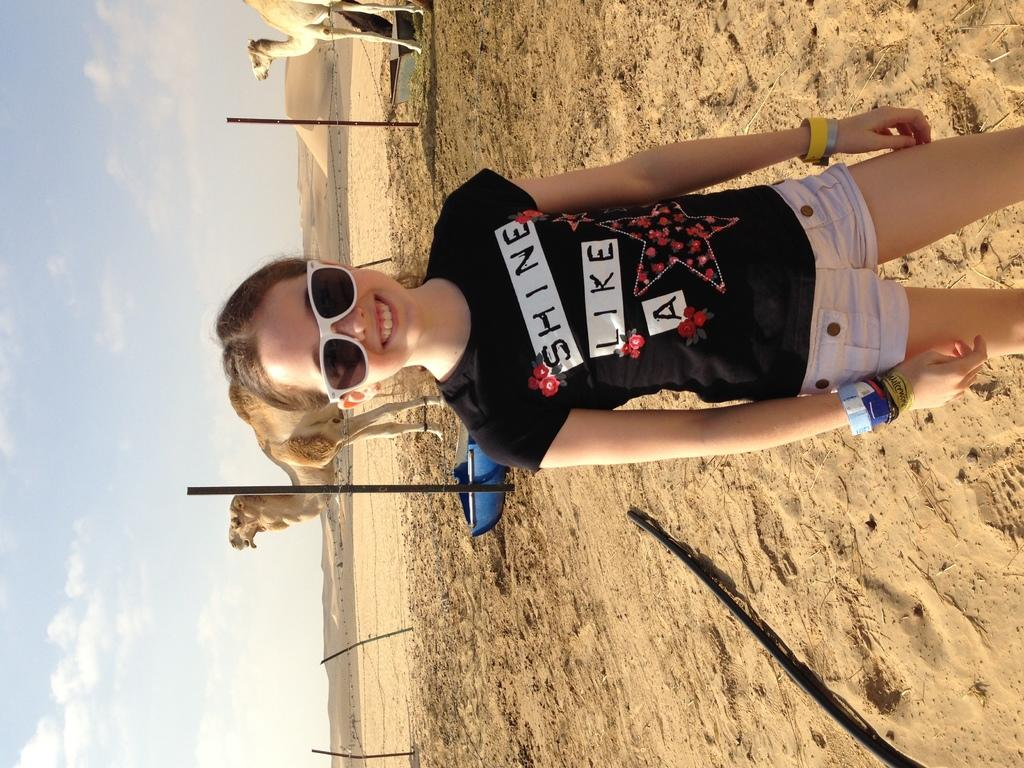What is the main subject of the image? The main subject of the image is a girl. What is the girl wearing in the image? The girl is wearing goggles in the image. What expression does the girl have in the image? The girl is smiling in the image. What can be seen in the background of the image? There are camels and poles in the background of the image. What is the condition of the sky in the image? The sky is cloudy in the image. Can you tell me how many rings the girl is wearing on her fingers in the image? There is no indication in the image that the girl is wearing any rings on her fingers. What type of circle can be seen in the image? There is no circle present in the image. 